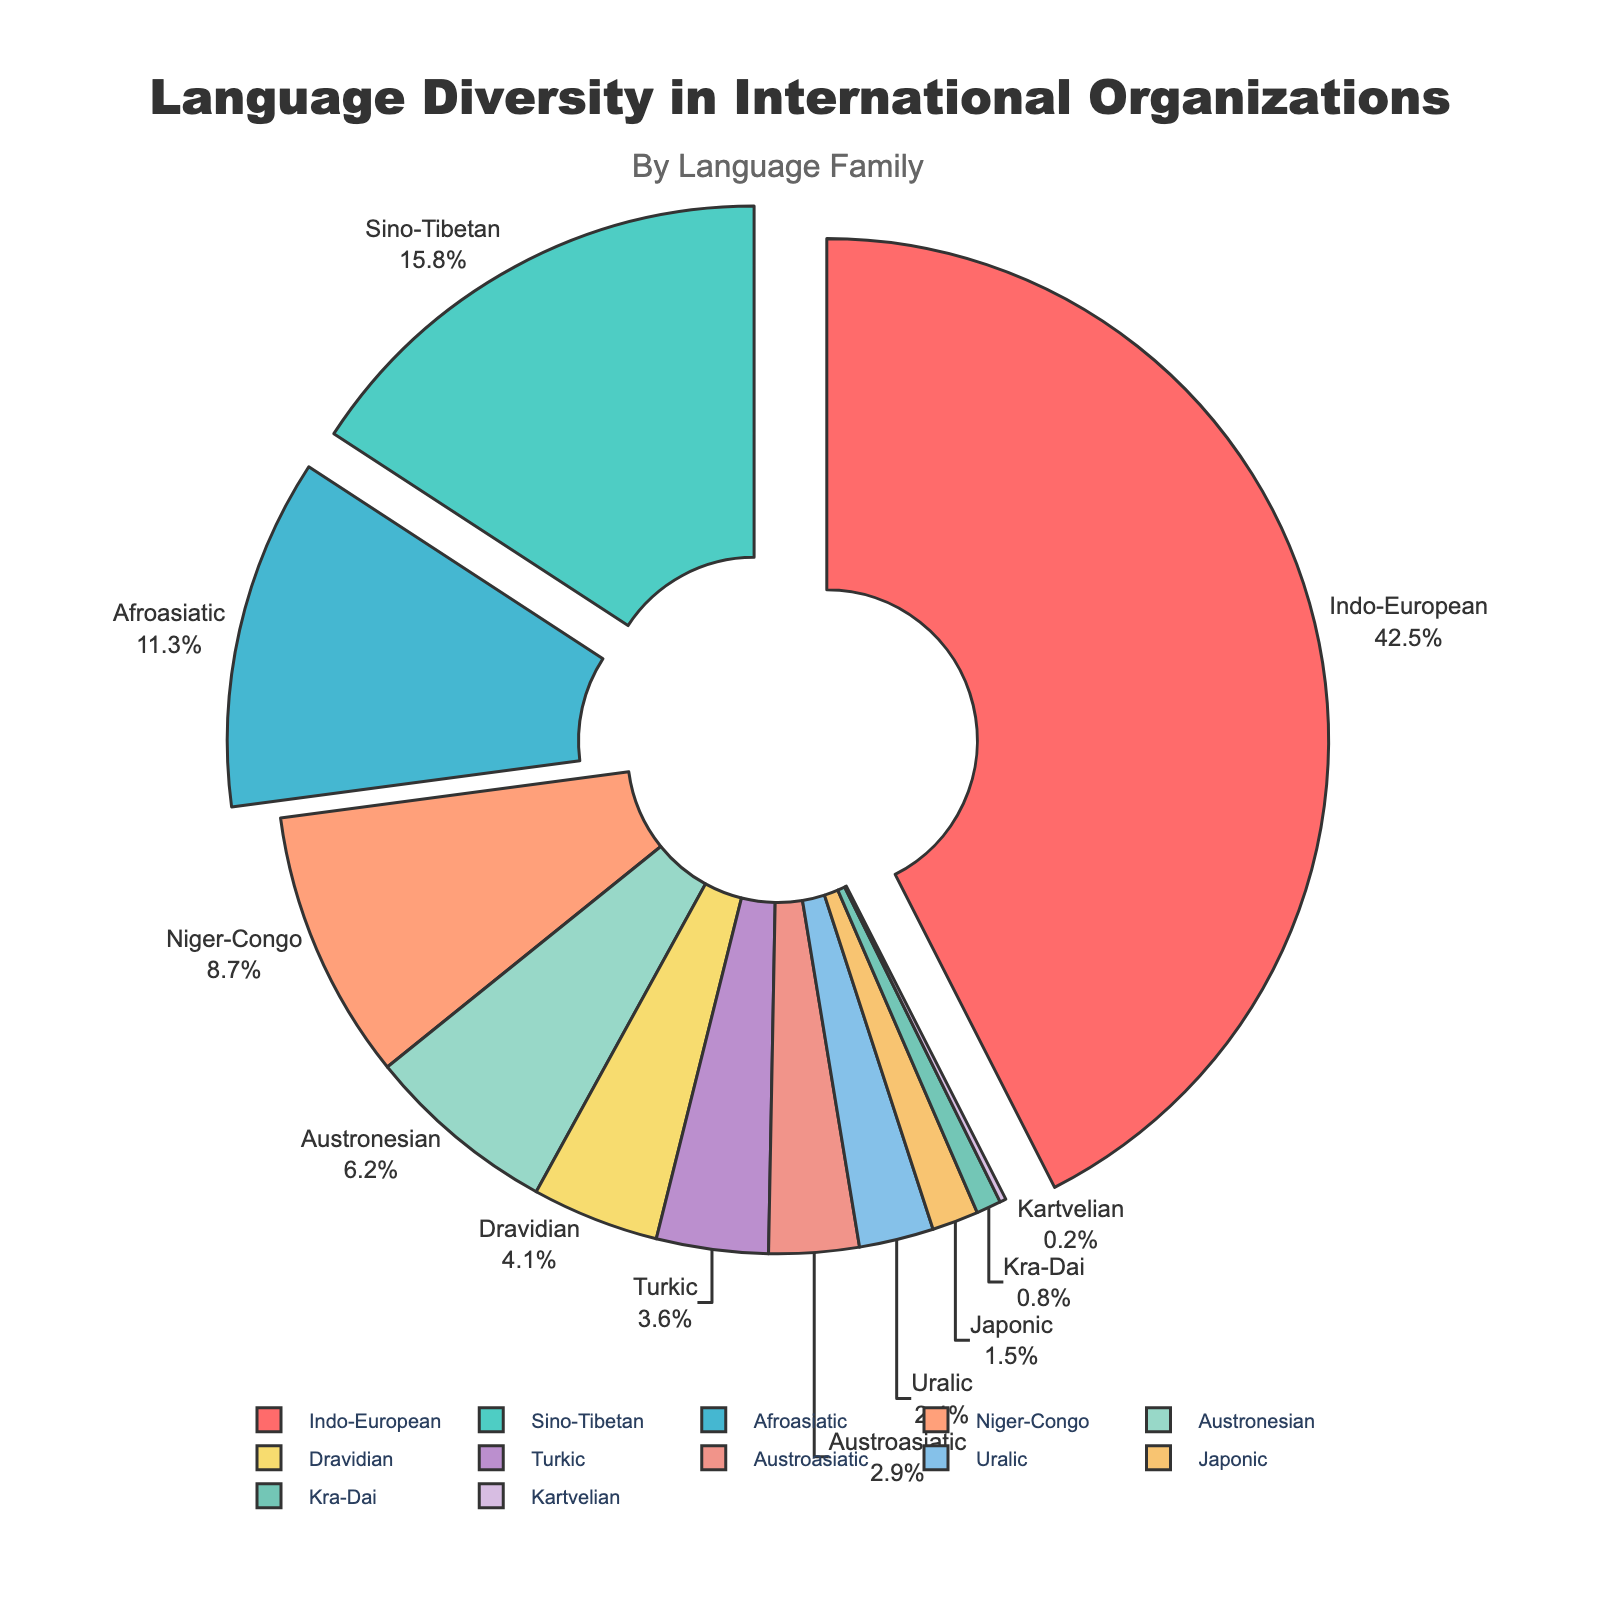Which language family has the largest percentage in the pie chart? The language family with the largest percentage in the pie chart is identified by the biggest slice. This is labeled "Indo-European" with a specific percentage of 42.5%.
Answer: Indo-European What's the combined percentage of the Sino-Tibetan and Niger-Congo language families? To find the combined percentage, sum the percentages of the Sino-Tibetan (15.8%) and Niger-Congo (8.7%) language families. 15.8 + 8.7 = 24.5%
Answer: 24.5% Which language families have a percentage greater than 10%? The slices labeled "Indo-European" and "Sino-Tibetan" are visually the largest and have percentages over 10%. The Indo-European has 42.5% and Sino-Tibetan 15.8%.
Answer: Indo-European, Sino-Tibetan What is the difference in percentage between the Afroasiatic and Austronesian language families? Subtract the percentage of the Austronesian (6.2%) from the Afroasiatic (11.3%) language family. 11.3 - 6.2 = 5.1%
Answer: 5.1% Which language family is represented by the smallest slice? The smallest slice on the pie chart corresponds to the language family labeled "Kartvelian" with 0.2%.
Answer: Kartvelian How many language families have a representation of less than 5%? Count the slices with percentages less than 5%: Dravidian (4.1%), Turkic (3.6%), Austroasiatic (2.9%), Uralic (2.4%), Japonic (1.5%), Kra-Dai (0.8%), and Kartvelian (0.2%), making a total of 7 language families.
Answer: 7 Which two language families together make up approximately one-third of the total percentage? Summing the percentages of Afroasiatic (11.3%) and Sino-Tibetan (15.8%) together gives us 27.1%. Checking Indo-European (42.5%) and Dravidian (4.1%) together gives us 46.6%. Finally, adding Afroasiatic (11.3%) and Niger-Congo (8.7%) gives us 20%. Therefore, none of these sums up approximately to one-third (33.33%), closest is Indo-European + Turkic equalling 46.1%, which isn't satisfactory.
Answer: None 